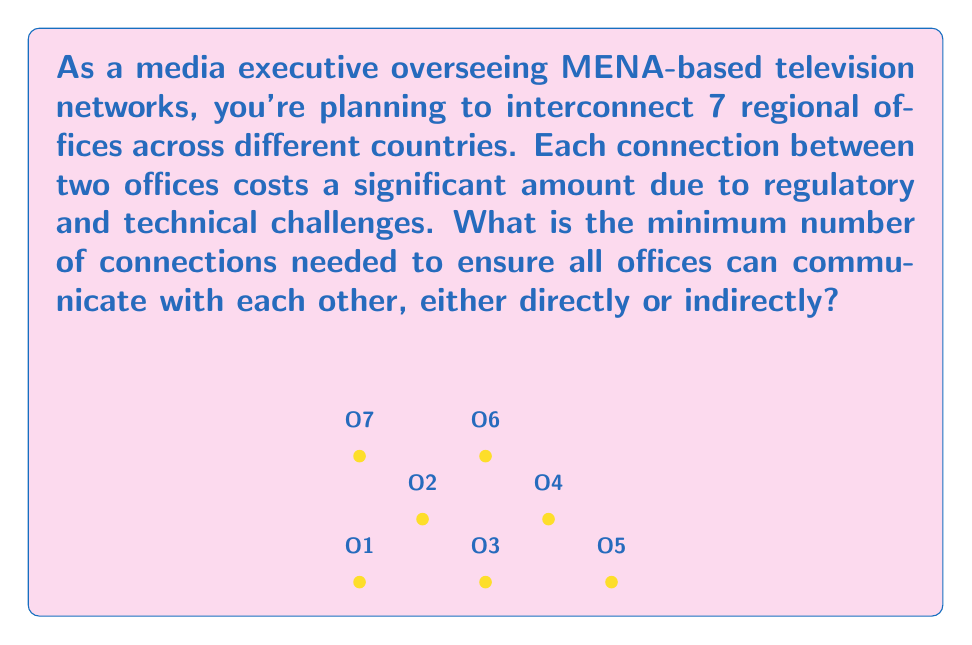Teach me how to tackle this problem. This problem can be solved using concepts from graph theory, specifically the properties of a minimum spanning tree.

1) In graph theory, each office can be represented as a vertex, and each connection as an edge.

2) The goal is to connect all vertices (offices) with the minimum number of edges (connections) while ensuring that all vertices are reachable from any other vertex.

3) This structure is known as a tree in graph theory. Specifically, we're looking for a spanning tree of the graph.

4) A fundamental property of trees is that for a tree with $n$ vertices, the number of edges is always $n-1$.

5) In this case, we have 7 offices (vertices), so the minimum number of connections (edges) needed is:

   $$\text{Number of connections} = n - 1 = 7 - 1 = 6$$

6) This solution ensures that all offices are connected while minimizing the number of expensive connections.

7) It's worth noting that there may be multiple ways to arrange these 6 connections, but the number of connections will always be 6 for 7 offices.
Answer: 6 connections 